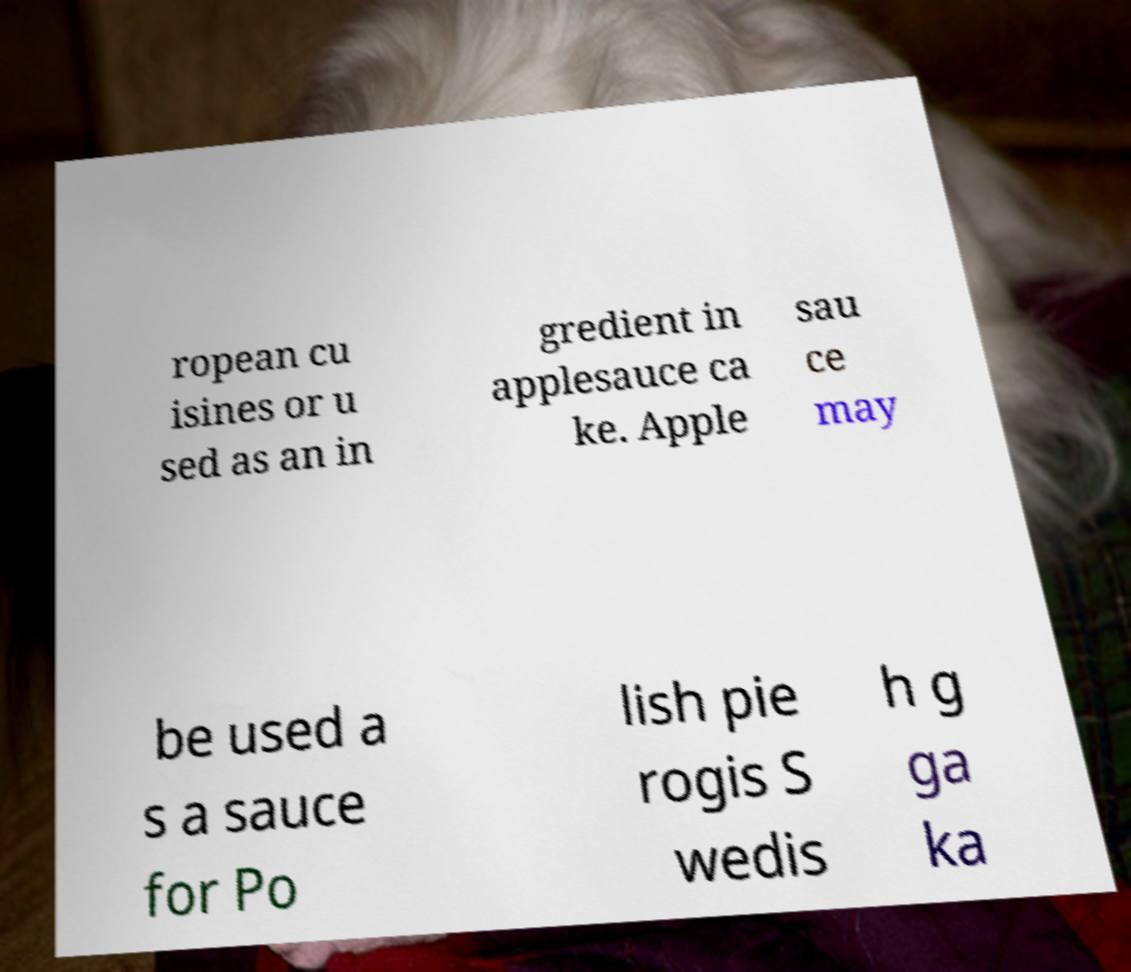Could you assist in decoding the text presented in this image and type it out clearly? ropean cu isines or u sed as an in gredient in applesauce ca ke. Apple sau ce may be used a s a sauce for Po lish pie rogis S wedis h g ga ka 